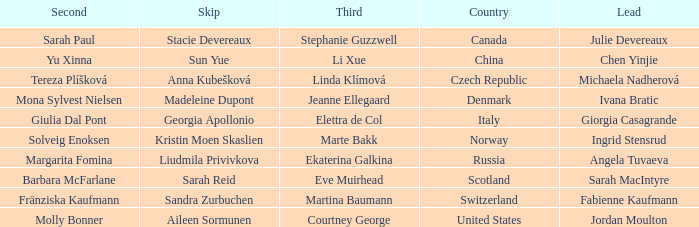What skip has denmark as the country? Madeleine Dupont. Parse the full table. {'header': ['Second', 'Skip', 'Third', 'Country', 'Lead'], 'rows': [['Sarah Paul', 'Stacie Devereaux', 'Stephanie Guzzwell', 'Canada', 'Julie Devereaux'], ['Yu Xinna', 'Sun Yue', 'Li Xue', 'China', 'Chen Yinjie'], ['Tereza Plíšková', 'Anna Kubešková', 'Linda Klímová', 'Czech Republic', 'Michaela Nadherová'], ['Mona Sylvest Nielsen', 'Madeleine Dupont', 'Jeanne Ellegaard', 'Denmark', 'Ivana Bratic'], ['Giulia Dal Pont', 'Georgia Apollonio', 'Elettra de Col', 'Italy', 'Giorgia Casagrande'], ['Solveig Enoksen', 'Kristin Moen Skaslien', 'Marte Bakk', 'Norway', 'Ingrid Stensrud'], ['Margarita Fomina', 'Liudmila Privivkova', 'Ekaterina Galkina', 'Russia', 'Angela Tuvaeva'], ['Barbara McFarlane', 'Sarah Reid', 'Eve Muirhead', 'Scotland', 'Sarah MacIntyre'], ['Fränziska Kaufmann', 'Sandra Zurbuchen', 'Martina Baumann', 'Switzerland', 'Fabienne Kaufmann'], ['Molly Bonner', 'Aileen Sormunen', 'Courtney George', 'United States', 'Jordan Moulton']]} 